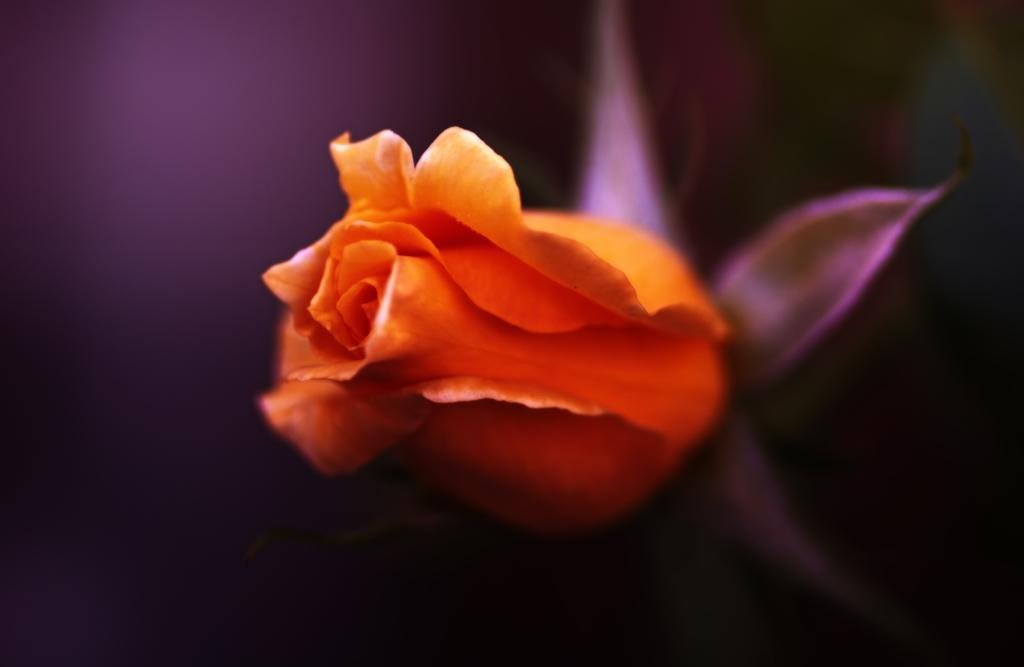What is the main subject in the foreground of the image? There is an orange color flower in the foreground of the image. What can be observed about the background of the image? The background of the image is blurred. What type of memory is stored in the office depicted in the image? There is no office or memory present in the image; it features an orange color flower in the foreground and a blurred background. How does the sail affect the movement of the flower in the image? There is no sail present in the image, and the flower is stationary in the foreground. 